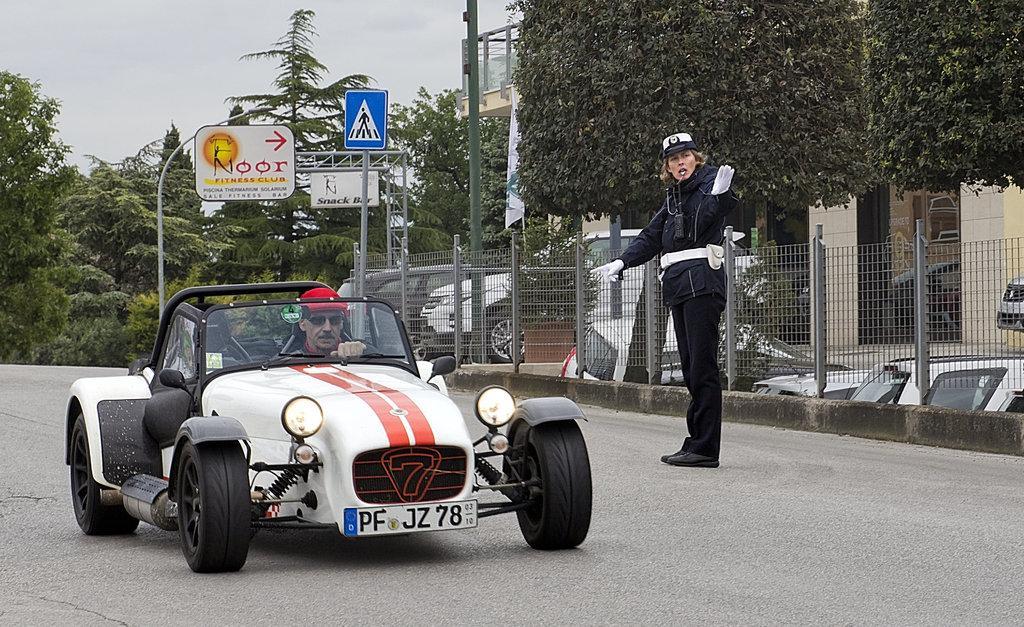Can you describe this image briefly? It is a wide road in the image. In which a vehicle is moving inside the vehicle there is a man who is driving the vehicle and wearing his goggles. On right side of the vehicle there is a woman and few cars and trees from right to left. In background there is hoardings and sky on top. 